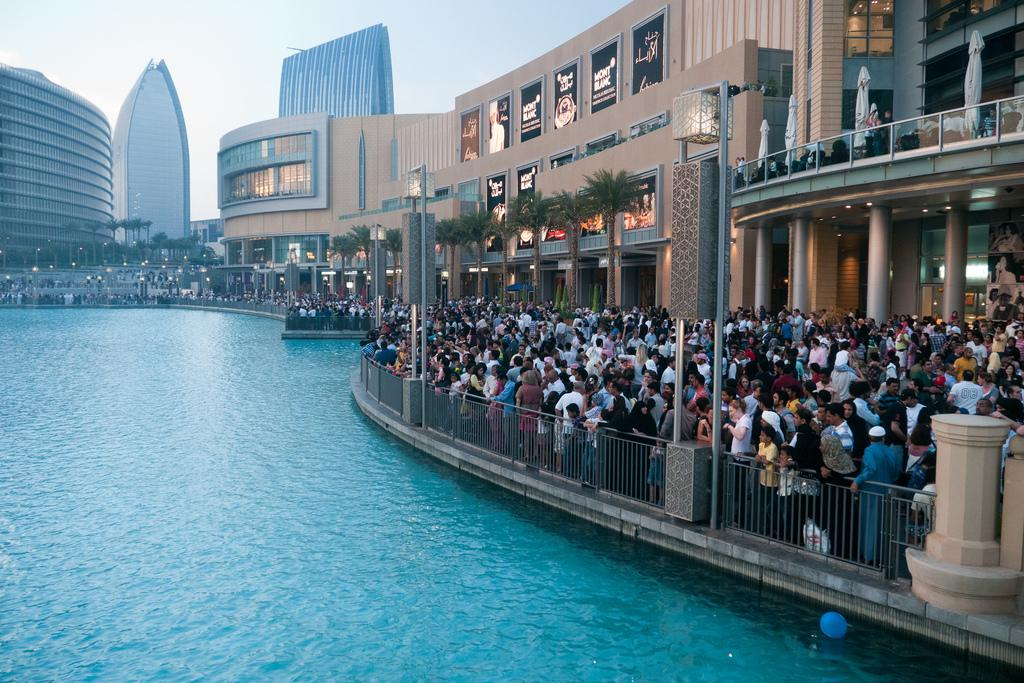What is the main subject in the center of the image? There is water in the center of the image. Where are the people located in the image? There is a group of persons on the right side of the image. What type of structures can be seen in the image? There are buildings in the image. What can be seen in the background of the image? There are trees and buildings in the background of the image. Can you see any chickens skating on the water in the image? There are no chickens or skating activities present in the image. 